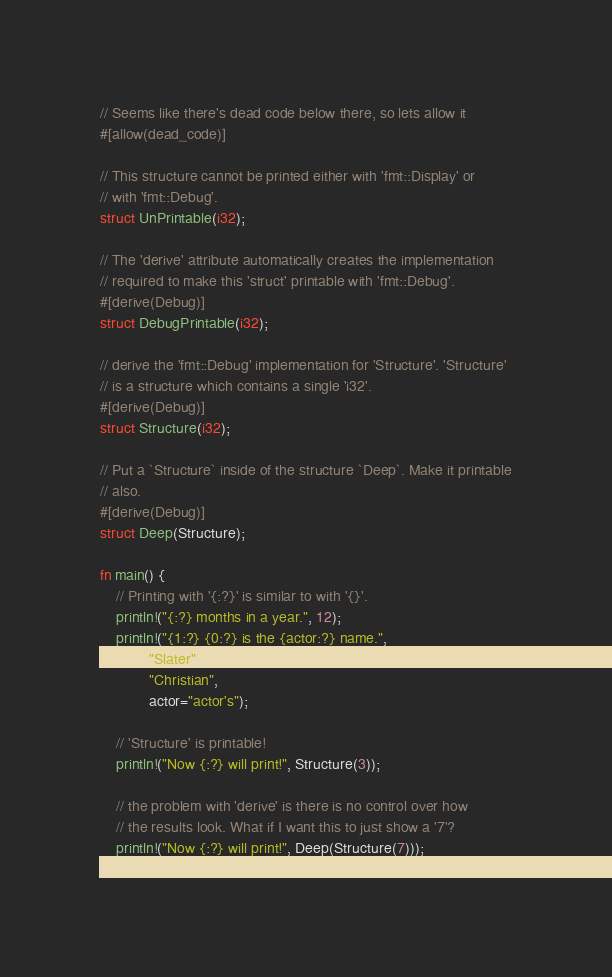Convert code to text. <code><loc_0><loc_0><loc_500><loc_500><_Rust_>// Seems like there's dead code below there, so lets allow it
#[allow(dead_code)]

// This structure cannot be printed either with 'fmt::Display' or
// with 'fmt::Debug'.
struct UnPrintable(i32);

// The 'derive' attribute automatically creates the implementation
// required to make this 'struct' printable with 'fmt::Debug'.
#[derive(Debug)]
struct DebugPrintable(i32);

// derive the 'fmt::Debug' implementation for 'Structure'. 'Structure'
// is a structure which contains a single 'i32'.
#[derive(Debug)]
struct Structure(i32);

// Put a `Structure` inside of the structure `Deep`. Make it printable
// also.
#[derive(Debug)]
struct Deep(Structure);

fn main() {
    // Printing with '{:?}' is similar to with '{}'.
    println!("{:?} months in a year.", 12);
    println!("{1:?} {0:?} is the {actor:?} name.",
            "Slater",
            "Christian",
            actor="actor's");

    // 'Structure' is printable!
    println!("Now {:?} will print!", Structure(3));

    // the problem with 'derive' is there is no control over how
    // the results look. What if I want this to just show a '7'?
    println!("Now {:?} will print!", Deep(Structure(7)));
}</code> 